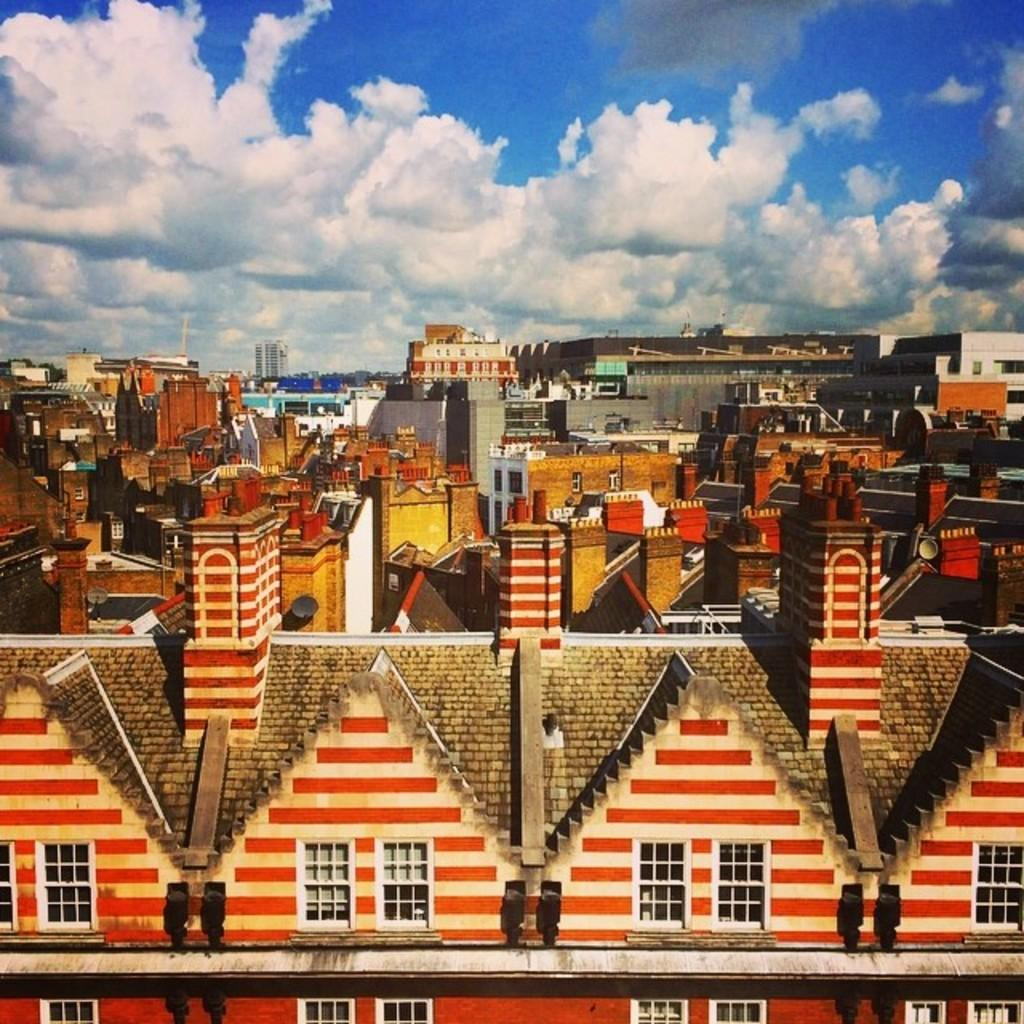What type of location is shown in the image? The image depicts a city. What structures can be seen in the city? There are buildings in the image. What is visible at the top of the image? The sky is visible at the top of the image. What can be observed in the sky? There are clouds in the sky. What is present in the foreground of the image? Windows are present in the foreground of the image. What type of vegetation can be seen in the background of the image? Trees are visible in the background of the image. What color of paint is being used to create the rock in the image? There is no rock present in the image, so it is not possible to determine the color of paint being used. 